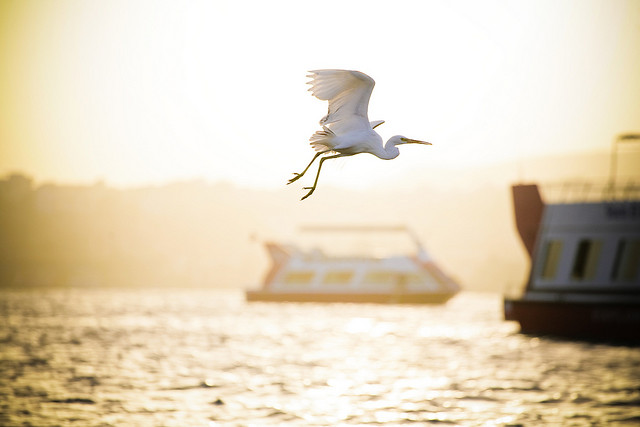Please provide a short description for this region: [0.38, 0.51, 0.72, 0.64]. A blurry boat in the middle of the image. 